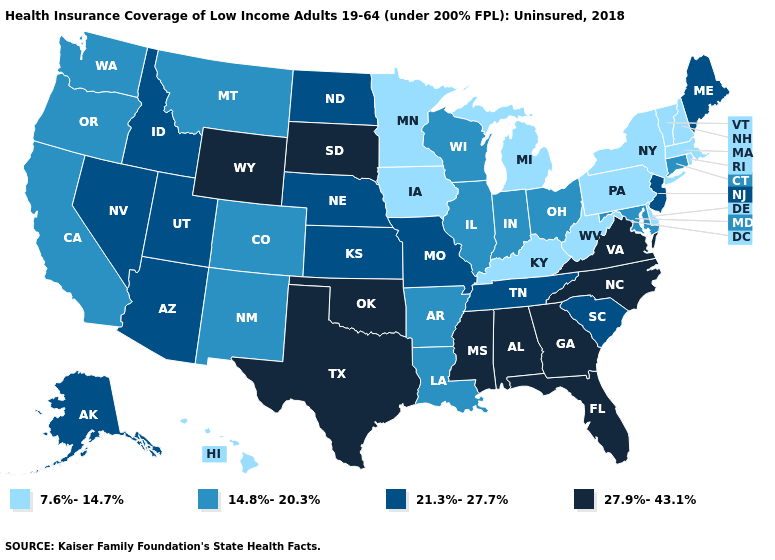Which states have the highest value in the USA?
Short answer required. Alabama, Florida, Georgia, Mississippi, North Carolina, Oklahoma, South Dakota, Texas, Virginia, Wyoming. Name the states that have a value in the range 7.6%-14.7%?
Concise answer only. Delaware, Hawaii, Iowa, Kentucky, Massachusetts, Michigan, Minnesota, New Hampshire, New York, Pennsylvania, Rhode Island, Vermont, West Virginia. What is the value of California?
Be succinct. 14.8%-20.3%. What is the value of South Dakota?
Short answer required. 27.9%-43.1%. Does Iowa have the highest value in the MidWest?
Quick response, please. No. Name the states that have a value in the range 14.8%-20.3%?
Quick response, please. Arkansas, California, Colorado, Connecticut, Illinois, Indiana, Louisiana, Maryland, Montana, New Mexico, Ohio, Oregon, Washington, Wisconsin. Does Minnesota have the lowest value in the USA?
Short answer required. Yes. Does Maine have the lowest value in the Northeast?
Answer briefly. No. Does West Virginia have the lowest value in the USA?
Short answer required. Yes. How many symbols are there in the legend?
Short answer required. 4. What is the highest value in the USA?
Concise answer only. 27.9%-43.1%. Does Maine have the lowest value in the Northeast?
Answer briefly. No. What is the value of Illinois?
Write a very short answer. 14.8%-20.3%. What is the highest value in the MidWest ?
Concise answer only. 27.9%-43.1%. 